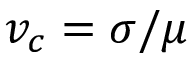<formula> <loc_0><loc_0><loc_500><loc_500>v _ { c } = \sigma / \mu</formula> 